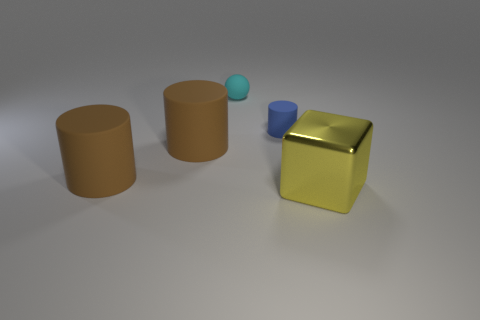Can you describe the lighting in the scene and how it affects the mood or atmosphere? The lighting in the scene is softly diffused, with shadows that are present but not sharply defined. This creates a calm and serene atmosphere. The objects are gently illuminated from an angle that's neither too harsh nor overly dramatic, contributing to an overall sense of simple tranquility and balance within the composition. 